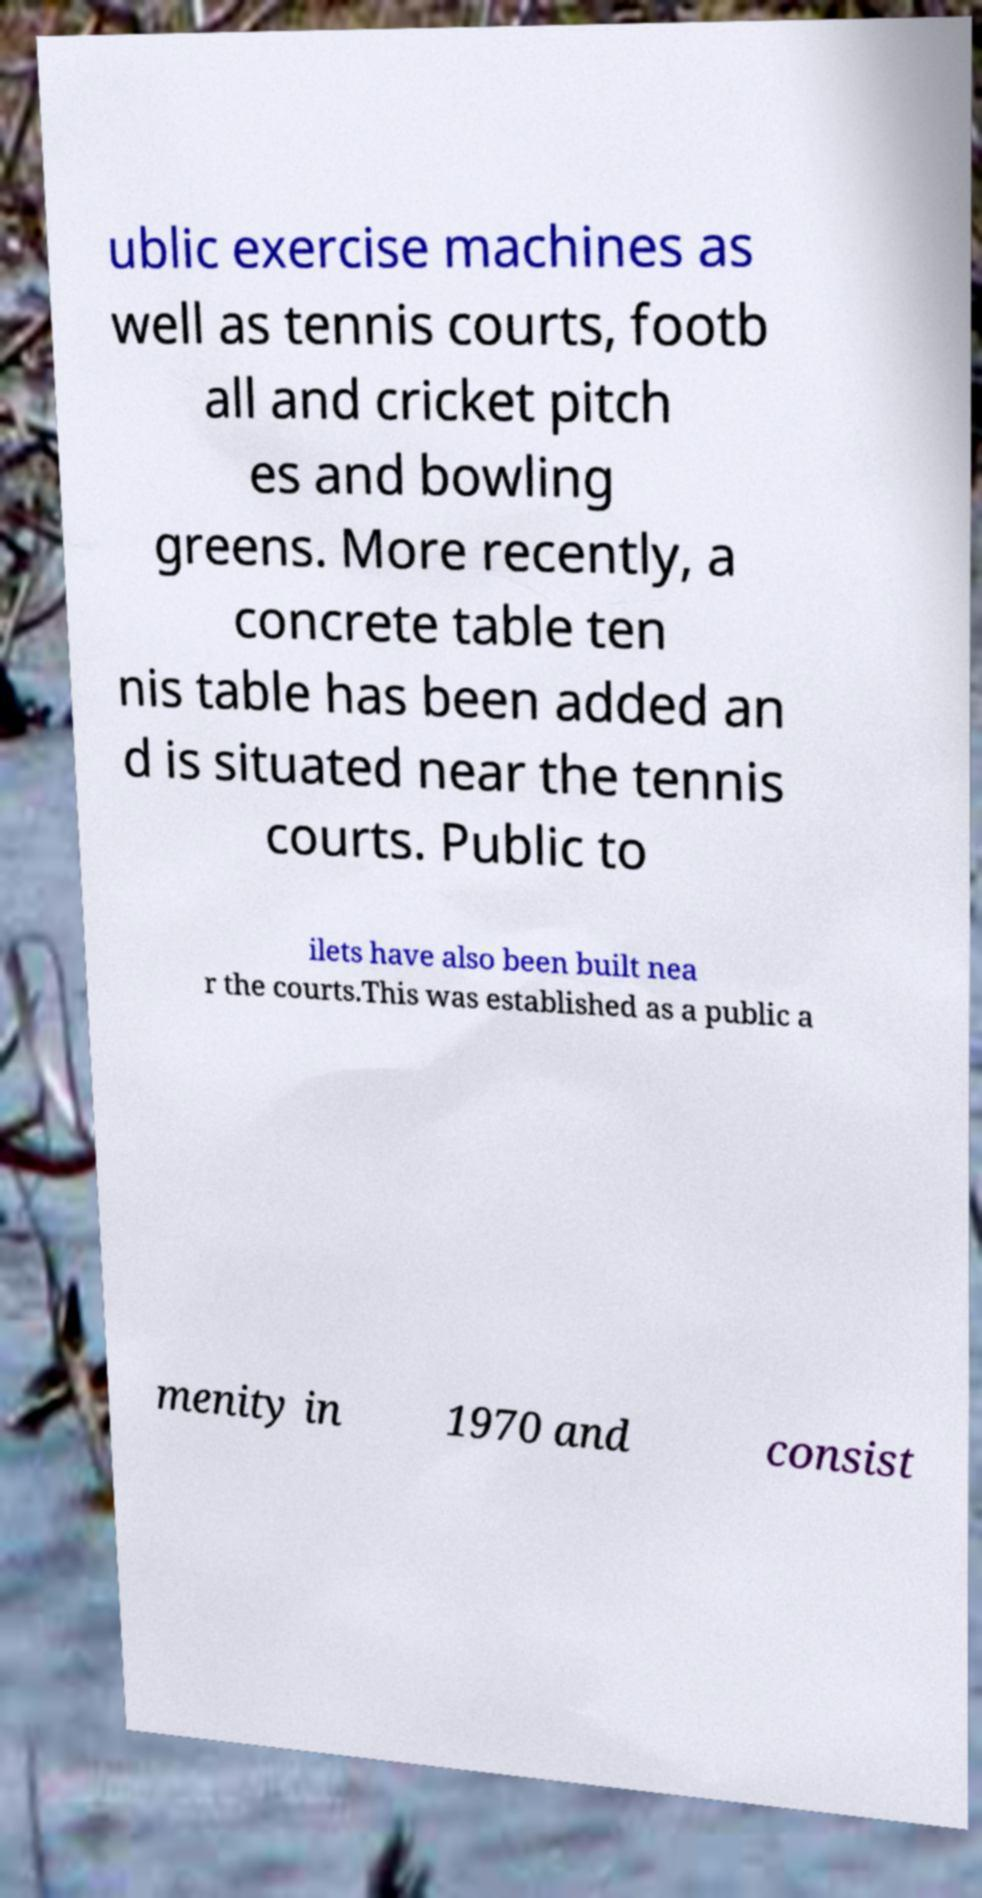Can you accurately transcribe the text from the provided image for me? ublic exercise machines as well as tennis courts, footb all and cricket pitch es and bowling greens. More recently, a concrete table ten nis table has been added an d is situated near the tennis courts. Public to ilets have also been built nea r the courts.This was established as a public a menity in 1970 and consist 